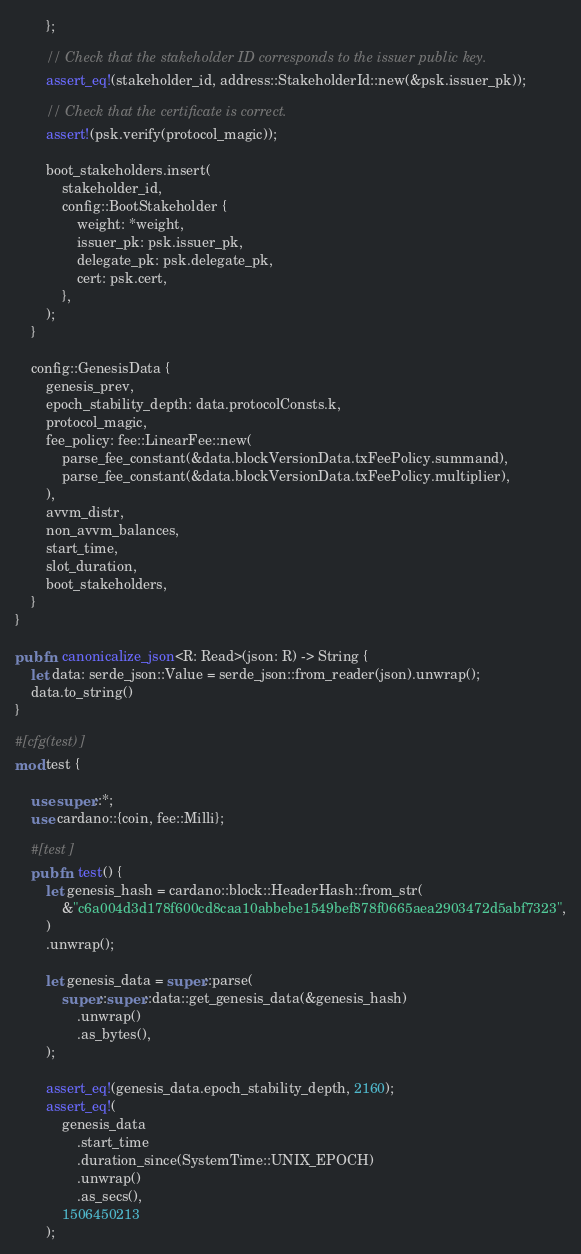<code> <loc_0><loc_0><loc_500><loc_500><_Rust_>        };

        // Check that the stakeholder ID corresponds to the issuer public key.
        assert_eq!(stakeholder_id, address::StakeholderId::new(&psk.issuer_pk));

        // Check that the certificate is correct.
        assert!(psk.verify(protocol_magic));

        boot_stakeholders.insert(
            stakeholder_id,
            config::BootStakeholder {
                weight: *weight,
                issuer_pk: psk.issuer_pk,
                delegate_pk: psk.delegate_pk,
                cert: psk.cert,
            },
        );
    }

    config::GenesisData {
        genesis_prev,
        epoch_stability_depth: data.protocolConsts.k,
        protocol_magic,
        fee_policy: fee::LinearFee::new(
            parse_fee_constant(&data.blockVersionData.txFeePolicy.summand),
            parse_fee_constant(&data.blockVersionData.txFeePolicy.multiplier),
        ),
        avvm_distr,
        non_avvm_balances,
        start_time,
        slot_duration,
        boot_stakeholders,
    }
}

pub fn canonicalize_json<R: Read>(json: R) -> String {
    let data: serde_json::Value = serde_json::from_reader(json).unwrap();
    data.to_string()
}

#[cfg(test)]
mod test {

    use super::*;
    use cardano::{coin, fee::Milli};

    #[test]
    pub fn test() {
        let genesis_hash = cardano::block::HeaderHash::from_str(
            &"c6a004d3d178f600cd8caa10abbebe1549bef878f0665aea2903472d5abf7323",
        )
        .unwrap();

        let genesis_data = super::parse(
            super::super::data::get_genesis_data(&genesis_hash)
                .unwrap()
                .as_bytes(),
        );

        assert_eq!(genesis_data.epoch_stability_depth, 2160);
        assert_eq!(
            genesis_data
                .start_time
                .duration_since(SystemTime::UNIX_EPOCH)
                .unwrap()
                .as_secs(),
            1506450213
        );</code> 